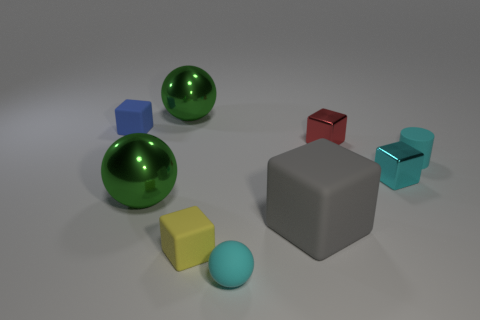If these objects were part of a collection, what might be the theme? If these objects were part of a collection, the theme might center around geometric shapes and the contrast in textures and colors. This could be an educational display to teach about different geometric forms and how they can be represented with various surface textures, ranging from matte to glossy, and a spectrum of color. 